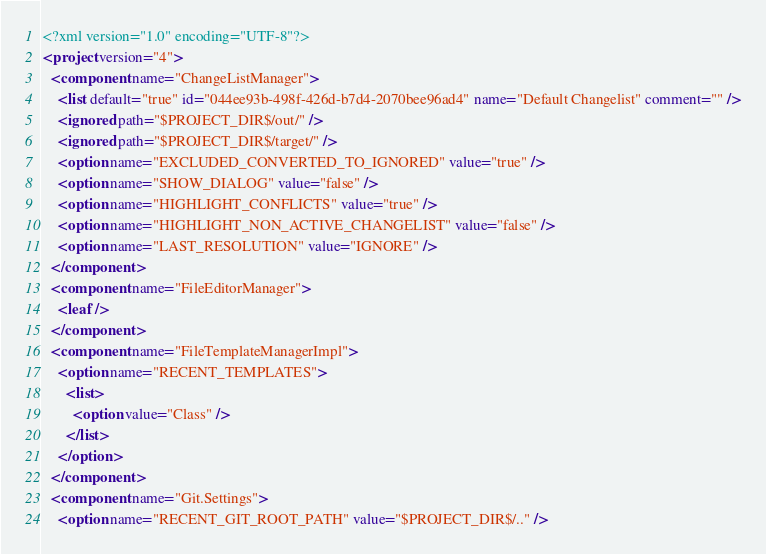<code> <loc_0><loc_0><loc_500><loc_500><_XML_><?xml version="1.0" encoding="UTF-8"?>
<project version="4">
  <component name="ChangeListManager">
    <list default="true" id="044ee93b-498f-426d-b7d4-2070bee96ad4" name="Default Changelist" comment="" />
    <ignored path="$PROJECT_DIR$/out/" />
    <ignored path="$PROJECT_DIR$/target/" />
    <option name="EXCLUDED_CONVERTED_TO_IGNORED" value="true" />
    <option name="SHOW_DIALOG" value="false" />
    <option name="HIGHLIGHT_CONFLICTS" value="true" />
    <option name="HIGHLIGHT_NON_ACTIVE_CHANGELIST" value="false" />
    <option name="LAST_RESOLUTION" value="IGNORE" />
  </component>
  <component name="FileEditorManager">
    <leaf />
  </component>
  <component name="FileTemplateManagerImpl">
    <option name="RECENT_TEMPLATES">
      <list>
        <option value="Class" />
      </list>
    </option>
  </component>
  <component name="Git.Settings">
    <option name="RECENT_GIT_ROOT_PATH" value="$PROJECT_DIR$/.." /></code> 